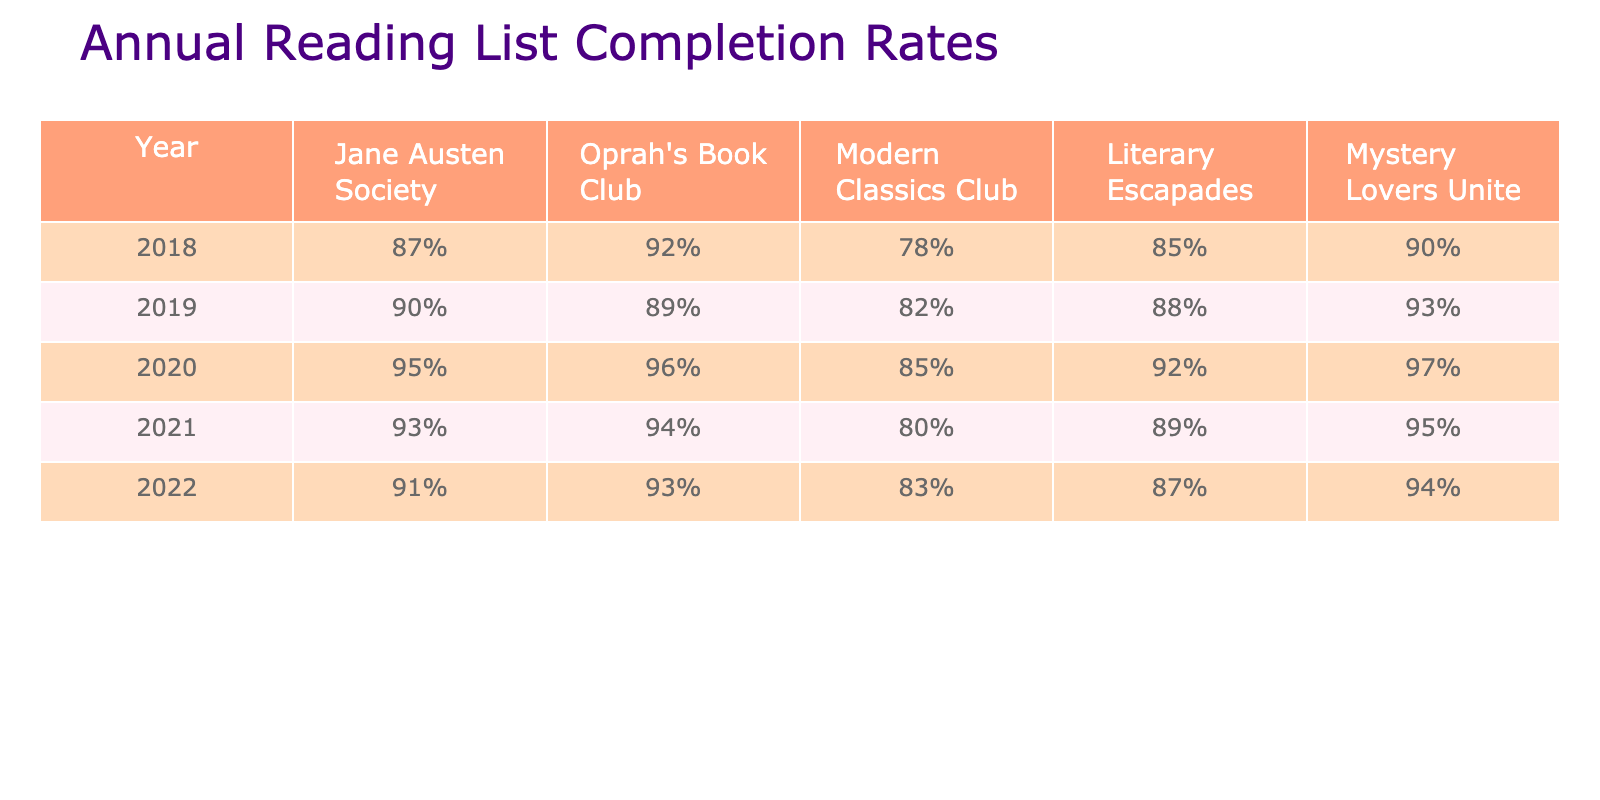What was the highest completion rate in 2020? The completion rate for each club in 2020 is: 95% for Jane Austen Society, 96% for Oprah's Book Club, 85% for Modern Classics Club, 92% for Literary Escapades, and 97% for Mystery Lovers Unite. The highest is therefore 97%.
Answer: 97% Which book club had the lowest completion rate in 2019? The completion rates for each club in 2019 are: 90% for Jane Austen Society, 89% for Oprah's Book Club, 82% for Modern Classics Club, 88% for Literary Escapades, and 93% for Mystery Lovers Unite. The lowest is 82%, which belongs to Modern Classics Club.
Answer: 82% What is the difference between Oprah's Book Club in 2018 and 2021? Oprah's Book Club had completion rates of 92% in 2018 and 94% in 2021. The difference is 94% - 92% = 2%.
Answer: 2% What is the average completion rate for Literary Escapades over the years? Adding the rates for Literary Escapades: 85% + 88% + 92% + 89% + 87% = 441%. Dividing by 5 years gives an average of 441% / 5 = 88.2%.
Answer: 88.2% Did Mystery Lovers Unite consistently have a higher completion rate than Jane Austen Society from 2018 to 2022? Looking at the values, Mystery Lovers Unite had rates of 90%, 93%, 97%, 95%, and 94%. Jane Austen Society had 87%, 90%, 95%, 93%, and 91%. In 2018, Mystery Lovers Unite was higher, but in 2019 they were equal. In 2020, Mystery Lovers Unite was higher, and in 2021, Mystery Lovers Unite was still higher. In 2022, Jane Austen Society was higher. Thus, they did not consistently have a higher rate.
Answer: No What trend can you observe for Jane Austen Society from 2018 to 2022? The completion rates for Jane Austen Society are 87%, 90%, 95%, 93%, and 91%. The trend shows an initial increase from 2018 to 2020, then a slight decline in 2021 and 2022.
Answer: Initial increase, then decline In which year did Modern Classics Club achieve its highest completion rate? The rates for Modern Classics Club were 78% in 2018, 82% in 2019, 85% in 2020, 80% in 2021, and 83% in 2022. The highest completion rate was in 2020, at 85%.
Answer: 2020 What is the sum of completion rates for Oprah's Book Club over all the years? Adding the completion rates: 92% + 89% + 96% + 94% + 93% = 464%.
Answer: 464% 